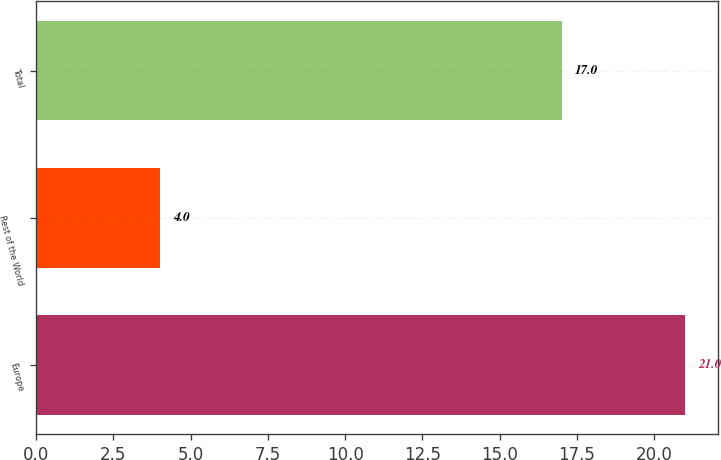Convert chart. <chart><loc_0><loc_0><loc_500><loc_500><bar_chart><fcel>Europe<fcel>Rest of the World<fcel>Total<nl><fcel>21<fcel>4<fcel>17<nl></chart> 